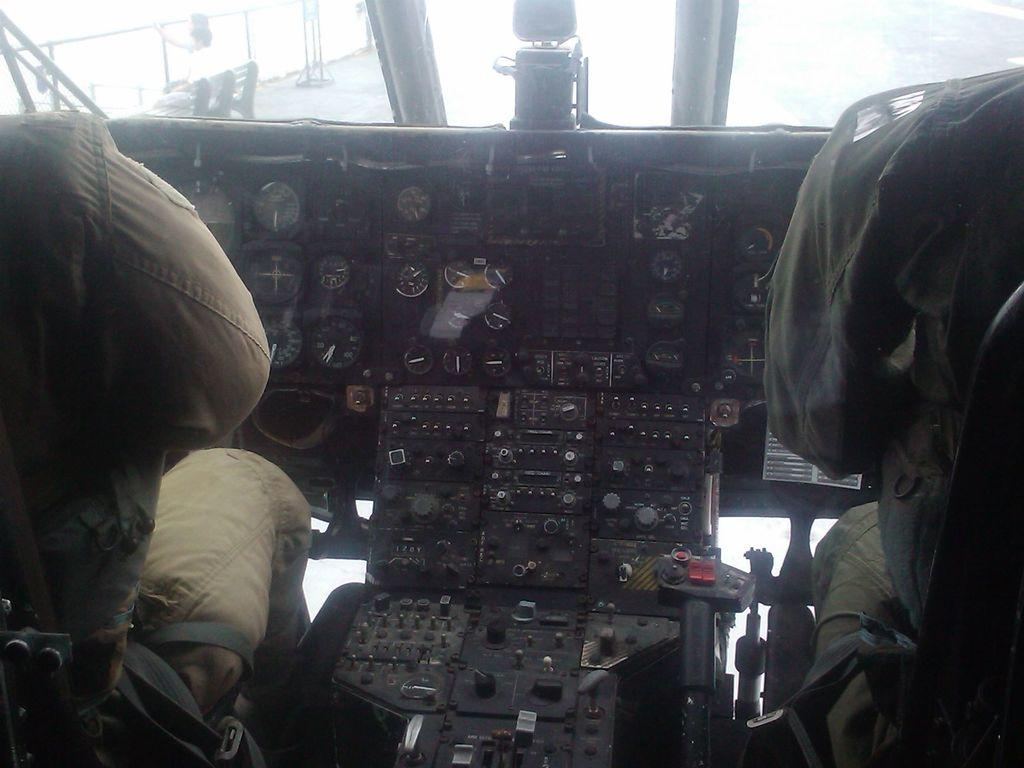Where was the image likely taken? The image appears to be taken inside an airplane. How many people are visible in the image? There are two persons sitting in the airplane. What other objects can be seen in the airplane? There are meters and other objects visible in the airplane. What type of needle is being used by the person in the image? There is no needle present in the image; it is taken inside an airplane with two persons sitting and other objects visible. 